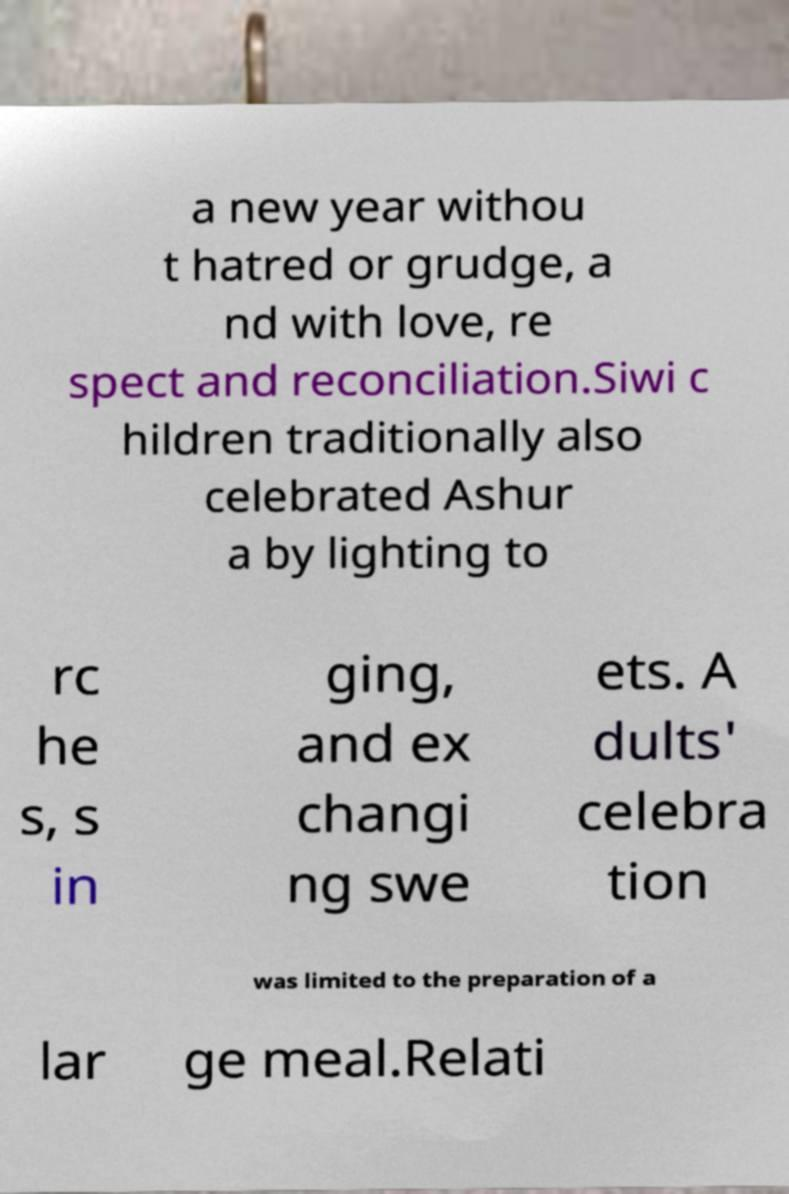Can you accurately transcribe the text from the provided image for me? a new year withou t hatred or grudge, a nd with love, re spect and reconciliation.Siwi c hildren traditionally also celebrated Ashur a by lighting to rc he s, s in ging, and ex changi ng swe ets. A dults' celebra tion was limited to the preparation of a lar ge meal.Relati 